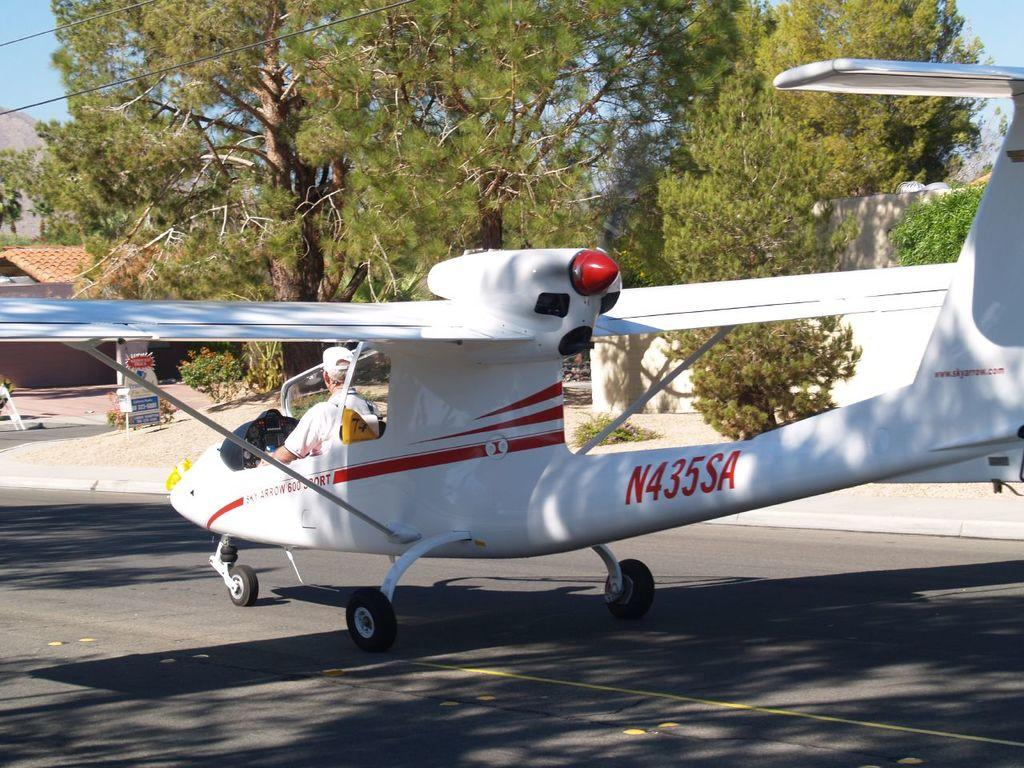What is the main subject of the image? The main subject of the image is an airplane. Where is the airplane located in the image? The airplane is on a runway. What can be seen in the background of the image? There are trees and the sky visible in the background of the image. What is the name of the person sitting in the airplane in the image? There is no person visible inside the airplane in the image, so it is not possible to determine their name. 